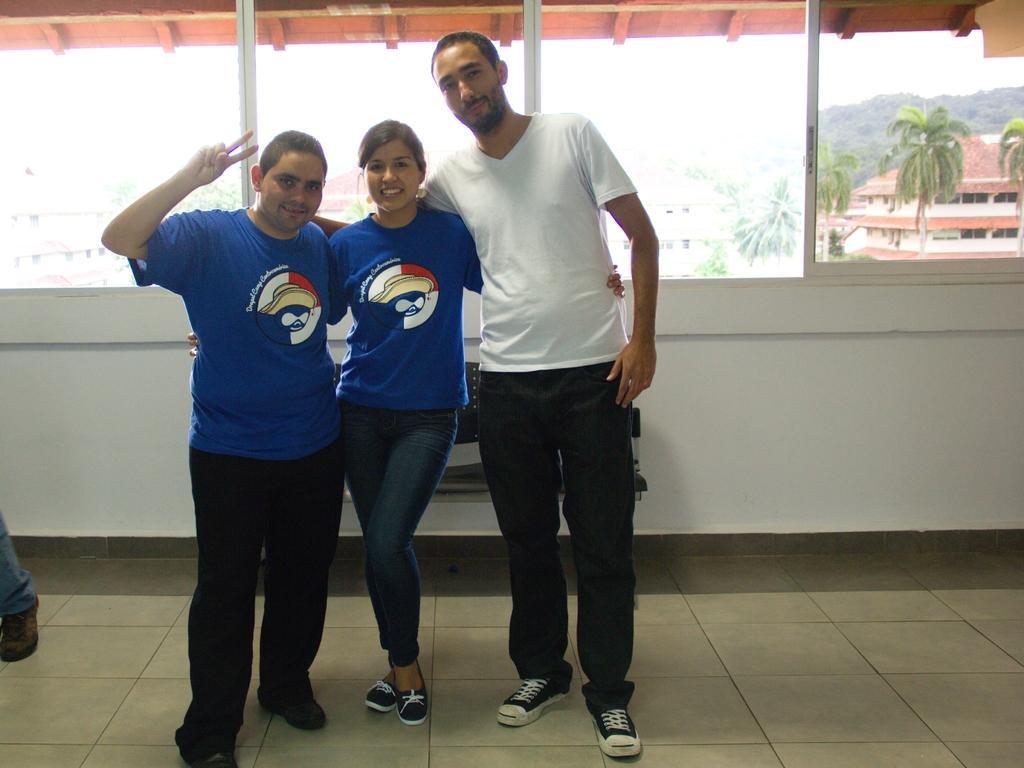Please provide a concise description of this image. The picture is taken in a house. In the center of the picture there are three people standing. In the the center of the picture there is a wall and a window, through the windows we can see buildings, trees, hills and sky. Sky is cloudy clouds. All the three people are smiling 